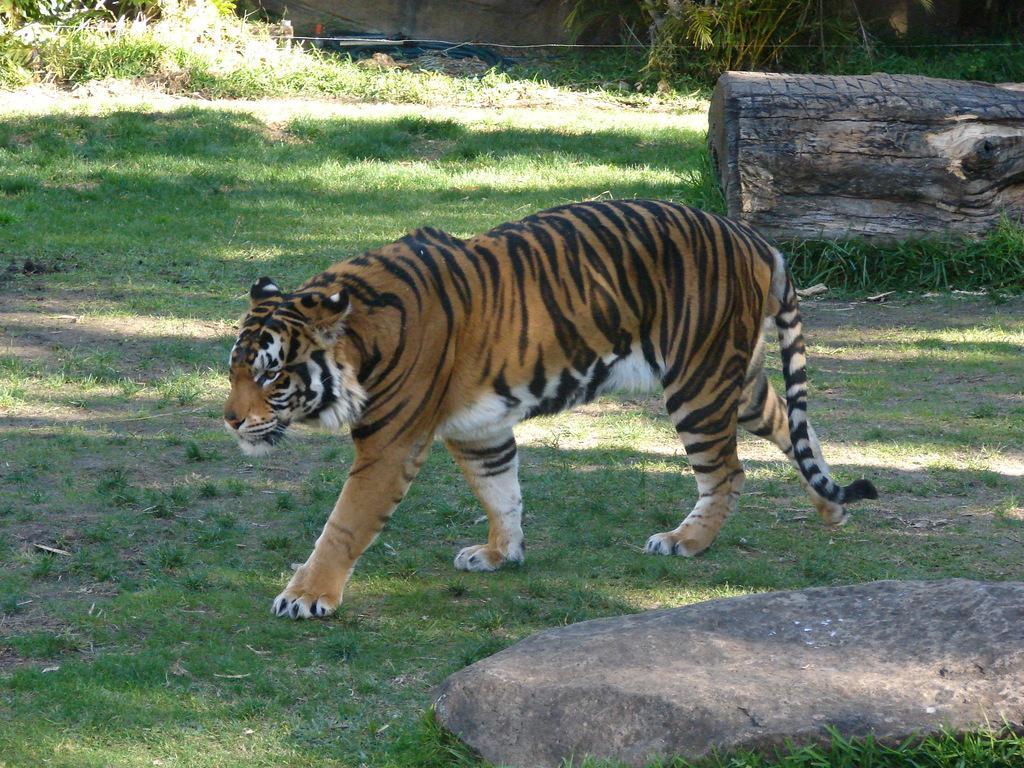In one or two sentences, can you explain what this image depicts? In this image there is a tiger. At the bottom of the image there is grass, stone. In the background of the image there is wall. There is a tree trunk. 